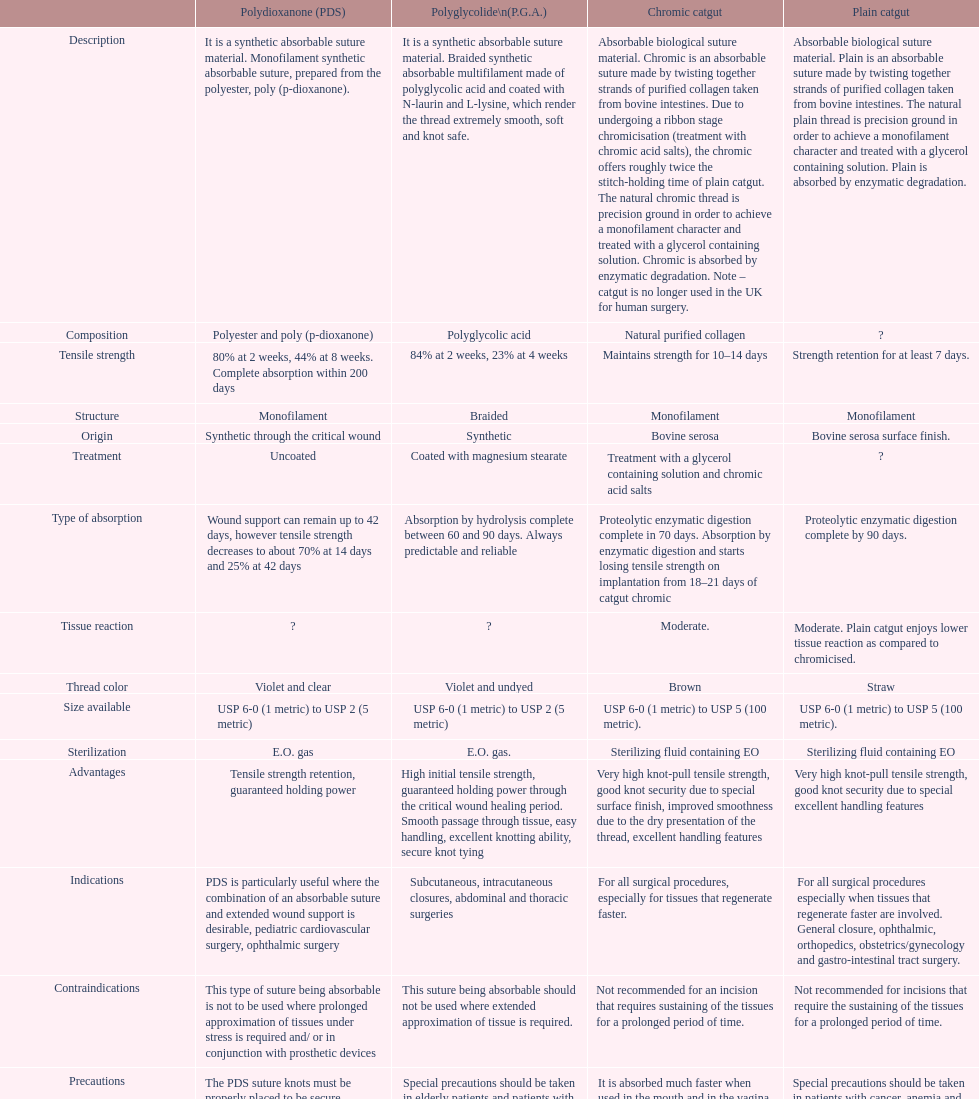What type of sutures are no longer used in the u.k. for human surgery? Chromic catgut. 